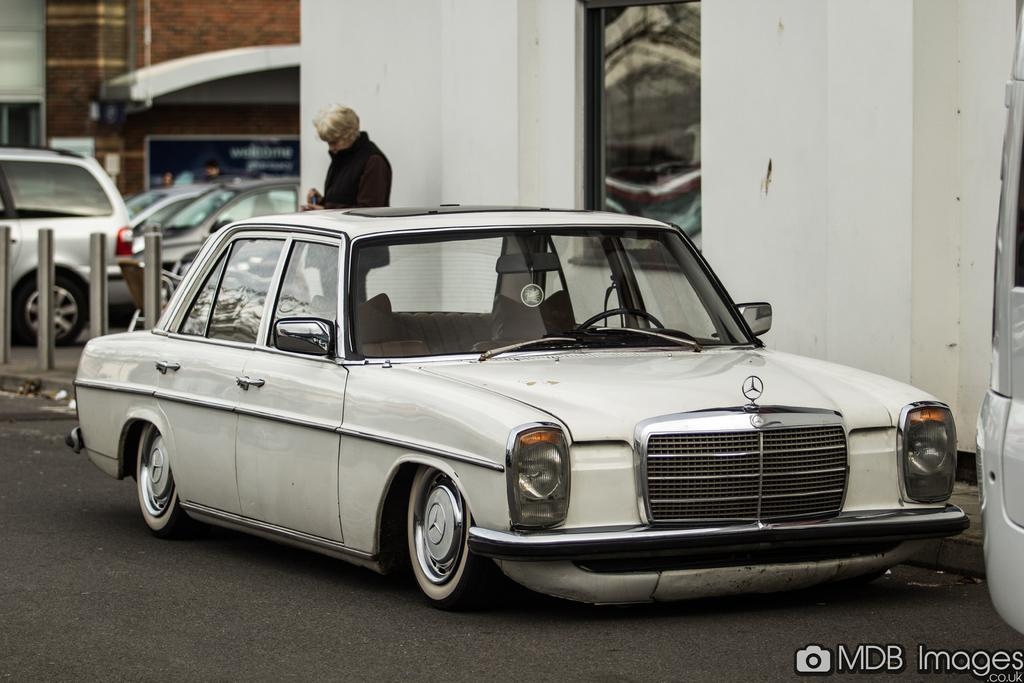What can be seen occupying the parking slots in the image? There are motor vehicles parked in the slot. What are the motor vehicles doing in the image? Motor vehicles are on the road. What safety feature is present in the image? Barrier poles are present. What type of visual communication is visible in the image? There is an advertisement visible. What type of structures are in the image? Buildings are in the image. Where is a person located in the image? A person is standing on the footpath. What is the taste of the advertisement in the image? The advertisement in the image does not have a taste, as it is a visual form of communication. Can you see any animals in the image? There are no animals present in the image. 